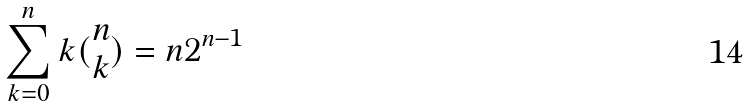<formula> <loc_0><loc_0><loc_500><loc_500>\sum _ { k = 0 } ^ { n } k ( \begin{matrix} n \\ k \end{matrix} ) = n 2 ^ { n - 1 }</formula> 